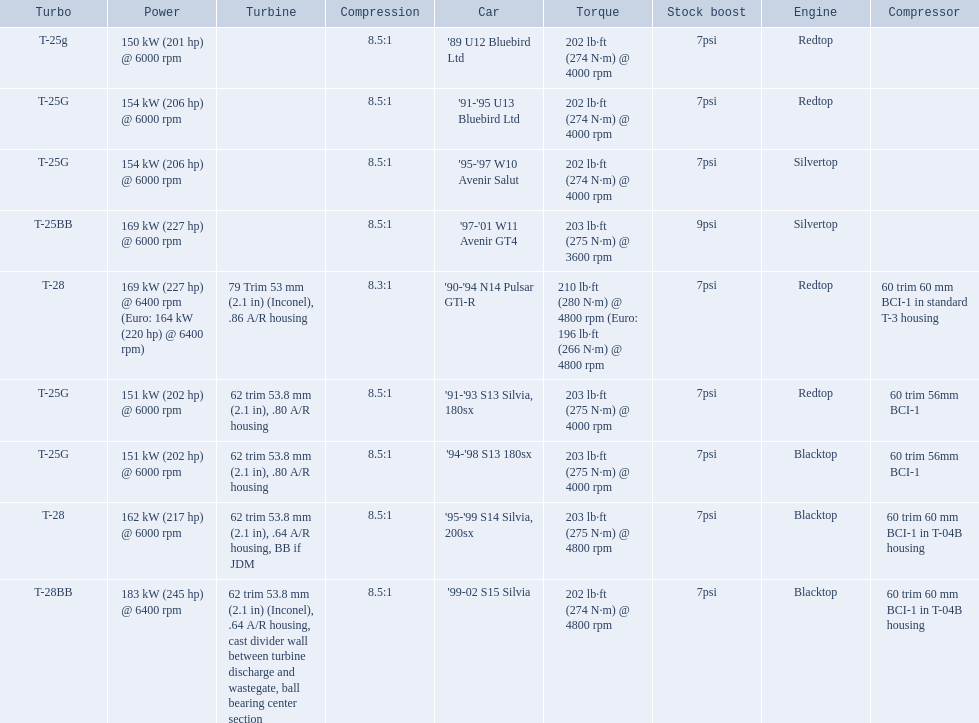Which cars list turbine details? '90-'94 N14 Pulsar GTi-R, '91-'93 S13 Silvia, 180sx, '94-'98 S13 180sx, '95-'99 S14 Silvia, 200sx, '99-02 S15 Silvia. Which of these hit their peak hp at the highest rpm? '90-'94 N14 Pulsar GTi-R, '99-02 S15 Silvia. Of those what is the compression of the only engine that isn't blacktop?? 8.3:1. 